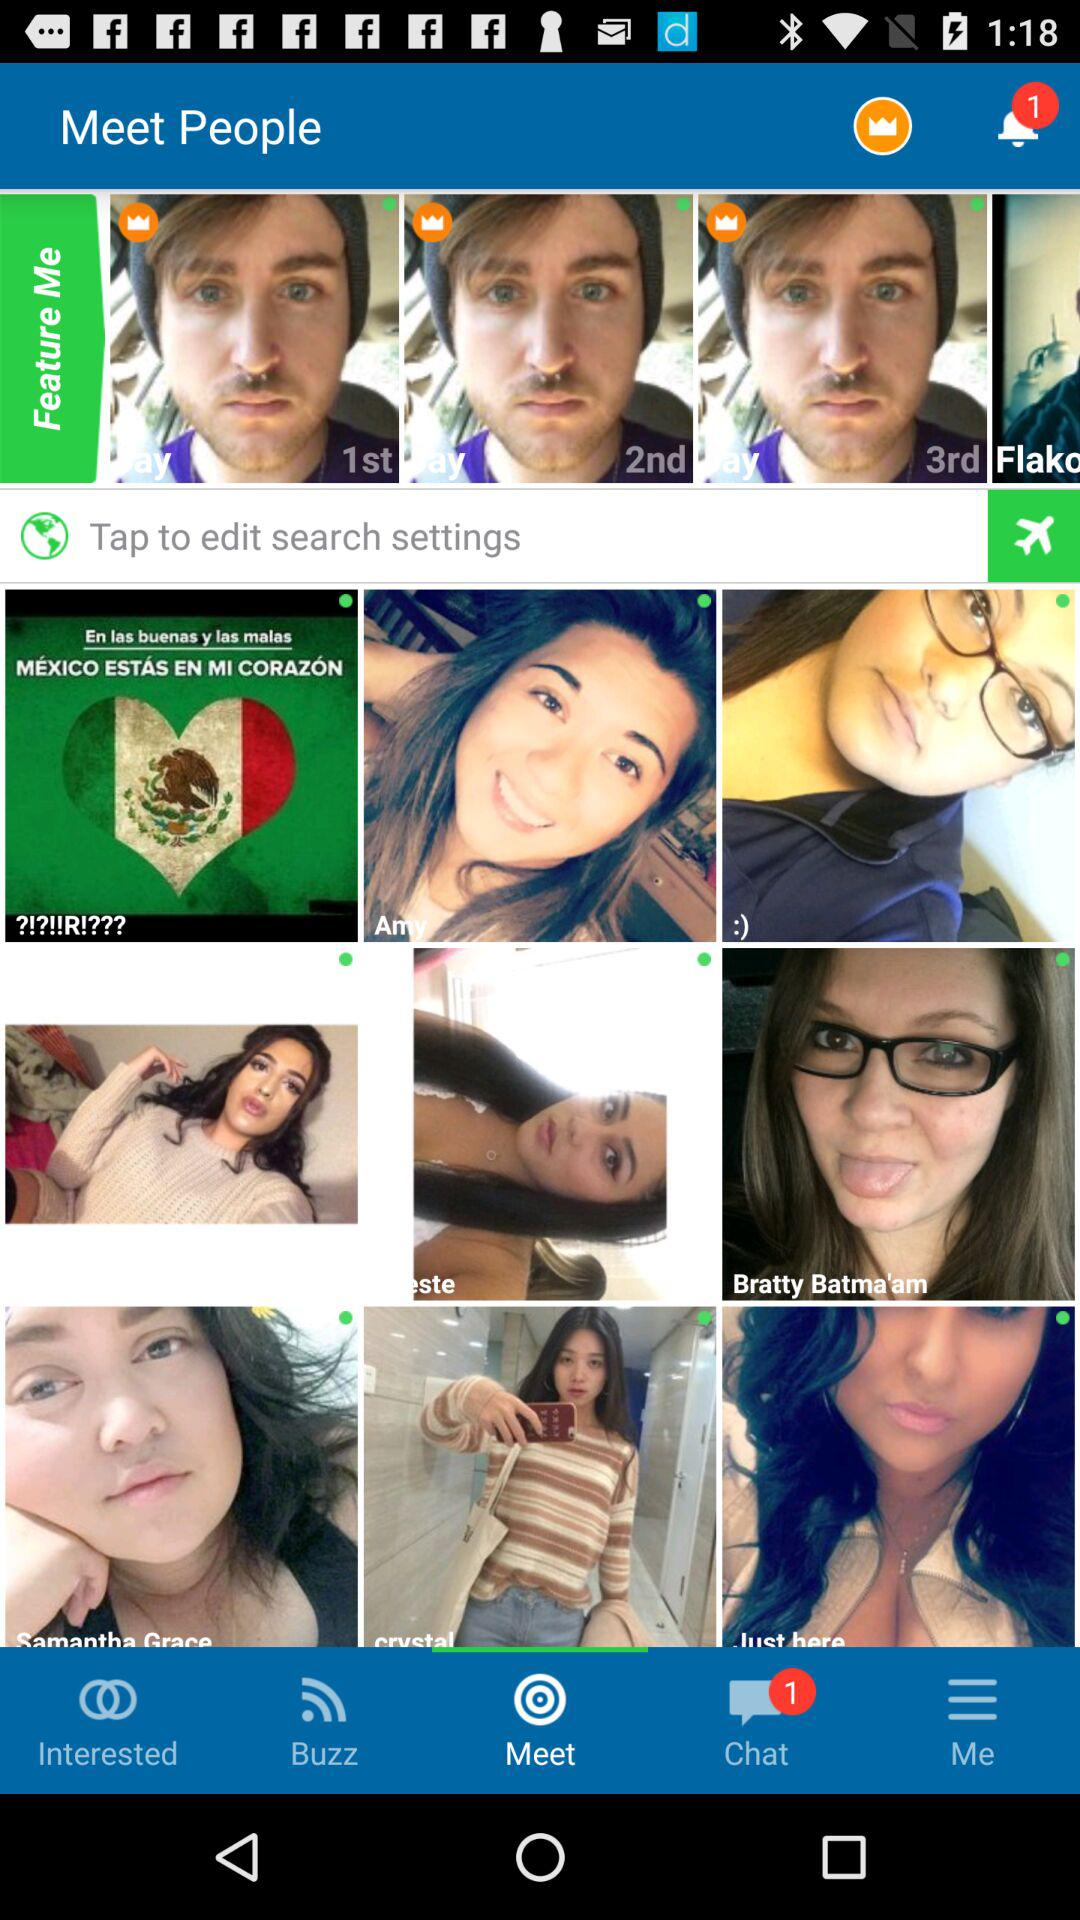How many notifications are there in "Buzz"?
When the provided information is insufficient, respond with <no answer>. <no answer> 